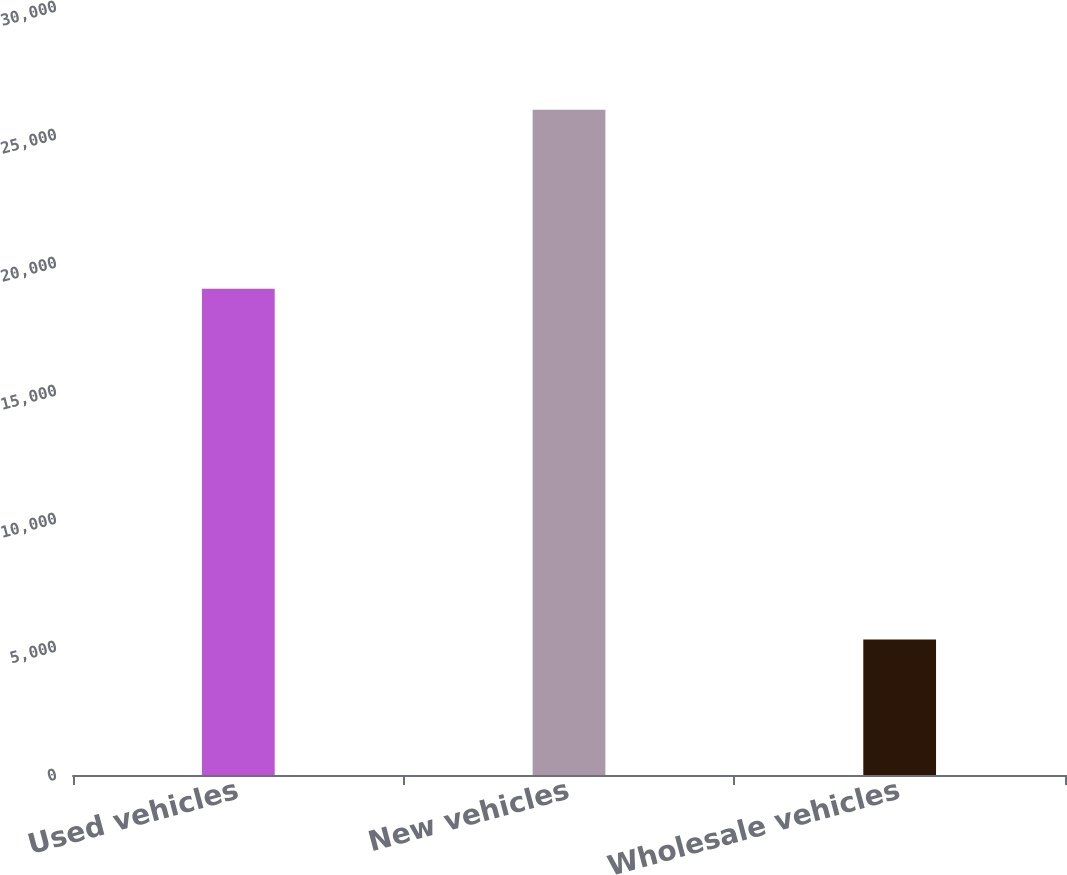Convert chart to OTSL. <chart><loc_0><loc_0><loc_500><loc_500><bar_chart><fcel>Used vehicles<fcel>New vehicles<fcel>Wholesale vehicles<nl><fcel>18995<fcel>25986<fcel>5291<nl></chart> 